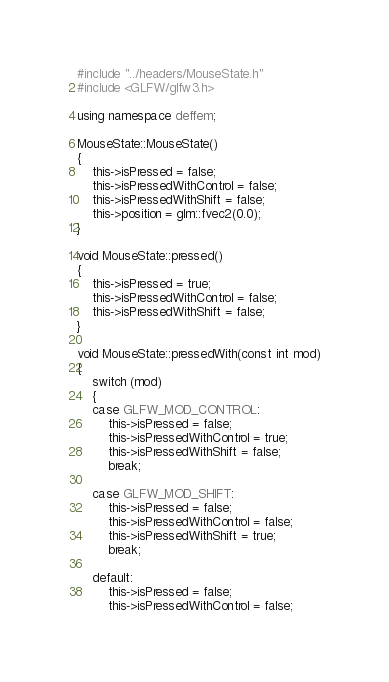<code> <loc_0><loc_0><loc_500><loc_500><_C++_>#include "../headers/MouseState.h"
#include <GLFW/glfw3.h>

using namespace deffem;

MouseState::MouseState()
{
    this->isPressed = false;
    this->isPressedWithControl = false;
    this->isPressedWithShift = false;
    this->position = glm::fvec2(0.0);
}

void MouseState::pressed()
{
    this->isPressed = true;
    this->isPressedWithControl = false;
    this->isPressedWithShift = false;
}

void MouseState::pressedWith(const int mod)
{
    switch (mod)
    {
    case GLFW_MOD_CONTROL:
        this->isPressed = false;
        this->isPressedWithControl = true;
        this->isPressedWithShift = false;
        break;

    case GLFW_MOD_SHIFT:
        this->isPressed = false;
        this->isPressedWithControl = false;
        this->isPressedWithShift = true;
        break;

    default:
        this->isPressed = false;
        this->isPressedWithControl = false;</code> 